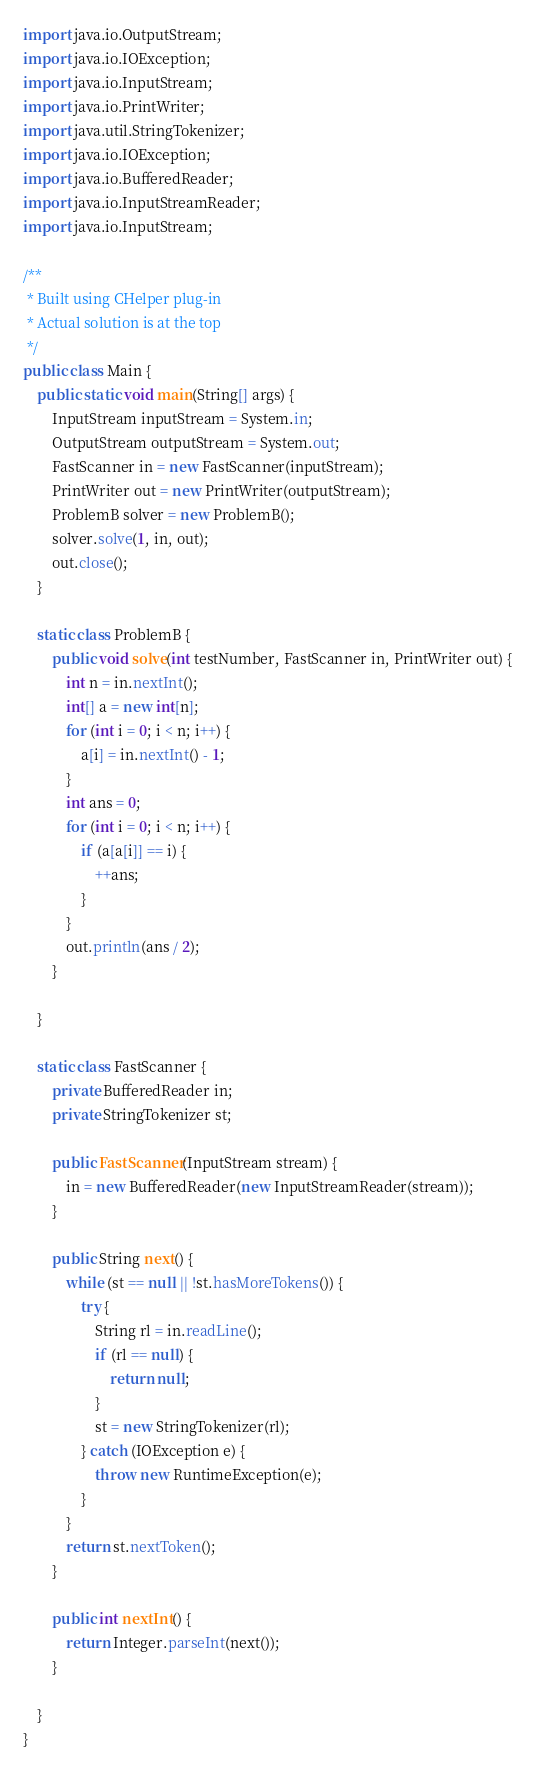Convert code to text. <code><loc_0><loc_0><loc_500><loc_500><_Java_>import java.io.OutputStream;
import java.io.IOException;
import java.io.InputStream;
import java.io.PrintWriter;
import java.util.StringTokenizer;
import java.io.IOException;
import java.io.BufferedReader;
import java.io.InputStreamReader;
import java.io.InputStream;

/**
 * Built using CHelper plug-in
 * Actual solution is at the top
 */
public class Main {
	public static void main(String[] args) {
		InputStream inputStream = System.in;
		OutputStream outputStream = System.out;
		FastScanner in = new FastScanner(inputStream);
		PrintWriter out = new PrintWriter(outputStream);
		ProblemB solver = new ProblemB();
		solver.solve(1, in, out);
		out.close();
	}

	static class ProblemB {
		public void solve(int testNumber, FastScanner in, PrintWriter out) {
			int n = in.nextInt();
			int[] a = new int[n];
			for (int i = 0; i < n; i++) {
				a[i] = in.nextInt() - 1;
			}
			int ans = 0;
			for (int i = 0; i < n; i++) {
				if (a[a[i]] == i) {
					++ans;
				}
			}
			out.println(ans / 2);
		}

	}

	static class FastScanner {
		private BufferedReader in;
		private StringTokenizer st;

		public FastScanner(InputStream stream) {
			in = new BufferedReader(new InputStreamReader(stream));
		}

		public String next() {
			while (st == null || !st.hasMoreTokens()) {
				try {
					String rl = in.readLine();
					if (rl == null) {
						return null;
					}
					st = new StringTokenizer(rl);
				} catch (IOException e) {
					throw new RuntimeException(e);
				}
			}
			return st.nextToken();
		}

		public int nextInt() {
			return Integer.parseInt(next());
		}

	}
}

</code> 